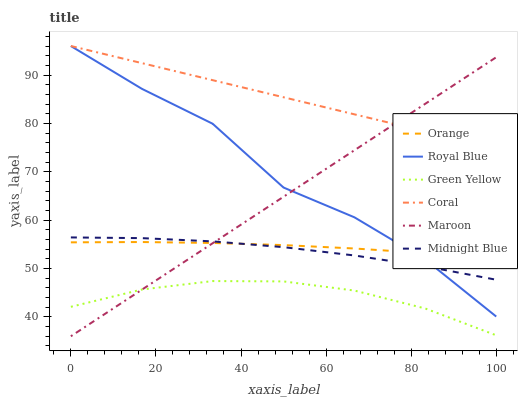Does Green Yellow have the minimum area under the curve?
Answer yes or no. Yes. Does Coral have the maximum area under the curve?
Answer yes or no. Yes. Does Maroon have the minimum area under the curve?
Answer yes or no. No. Does Maroon have the maximum area under the curve?
Answer yes or no. No. Is Maroon the smoothest?
Answer yes or no. Yes. Is Royal Blue the roughest?
Answer yes or no. Yes. Is Coral the smoothest?
Answer yes or no. No. Is Coral the roughest?
Answer yes or no. No. Does Coral have the lowest value?
Answer yes or no. No. Does Royal Blue have the highest value?
Answer yes or no. Yes. Does Maroon have the highest value?
Answer yes or no. No. Is Green Yellow less than Midnight Blue?
Answer yes or no. Yes. Is Coral greater than Green Yellow?
Answer yes or no. Yes. Does Green Yellow intersect Midnight Blue?
Answer yes or no. No. 